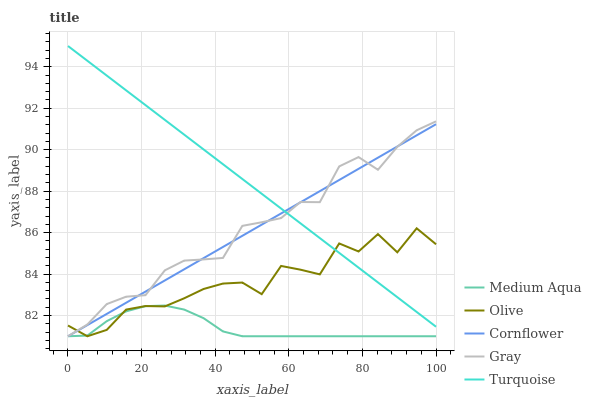Does Cornflower have the minimum area under the curve?
Answer yes or no. No. Does Cornflower have the maximum area under the curve?
Answer yes or no. No. Is Cornflower the smoothest?
Answer yes or no. No. Is Cornflower the roughest?
Answer yes or no. No. Does Turquoise have the lowest value?
Answer yes or no. No. Does Cornflower have the highest value?
Answer yes or no. No. Is Medium Aqua less than Turquoise?
Answer yes or no. Yes. Is Turquoise greater than Medium Aqua?
Answer yes or no. Yes. Does Medium Aqua intersect Turquoise?
Answer yes or no. No. 